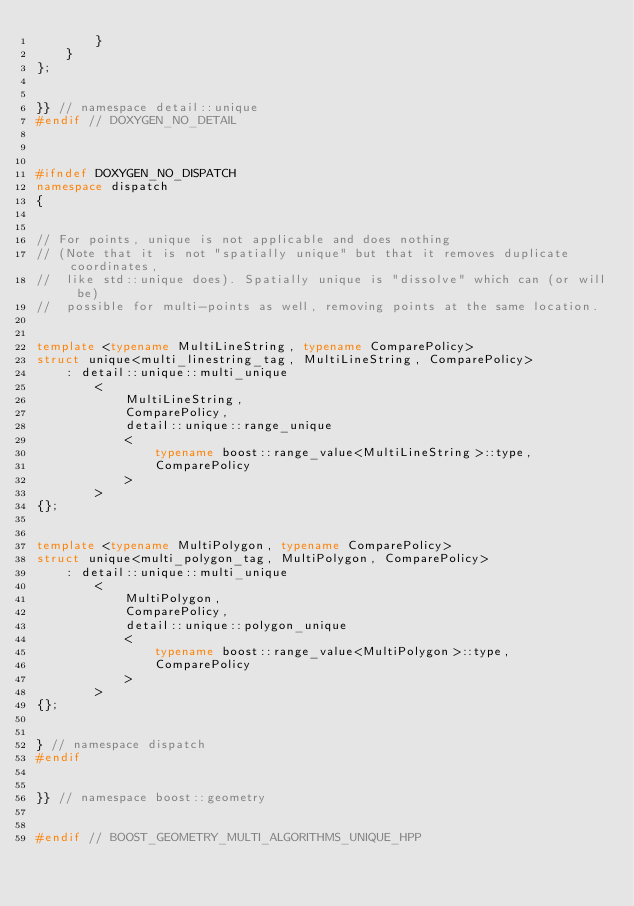Convert code to text. <code><loc_0><loc_0><loc_500><loc_500><_C++_>        }
    }
};


}} // namespace detail::unique
#endif // DOXYGEN_NO_DETAIL



#ifndef DOXYGEN_NO_DISPATCH
namespace dispatch
{


// For points, unique is not applicable and does nothing
// (Note that it is not "spatially unique" but that it removes duplicate coordinates,
//  like std::unique does). Spatially unique is "dissolve" which can (or will be)
//  possible for multi-points as well, removing points at the same location.


template <typename MultiLineString, typename ComparePolicy>
struct unique<multi_linestring_tag, MultiLineString, ComparePolicy>
    : detail::unique::multi_unique
        <
            MultiLineString,
            ComparePolicy,
            detail::unique::range_unique
            <
                typename boost::range_value<MultiLineString>::type,
                ComparePolicy
            >
        >
{};


template <typename MultiPolygon, typename ComparePolicy>
struct unique<multi_polygon_tag, MultiPolygon, ComparePolicy>
    : detail::unique::multi_unique
        <
            MultiPolygon,
            ComparePolicy,
            detail::unique::polygon_unique
            <
                typename boost::range_value<MultiPolygon>::type,
                ComparePolicy
            >
        >
{};


} // namespace dispatch
#endif


}} // namespace boost::geometry


#endif // BOOST_GEOMETRY_MULTI_ALGORITHMS_UNIQUE_HPP
</code> 